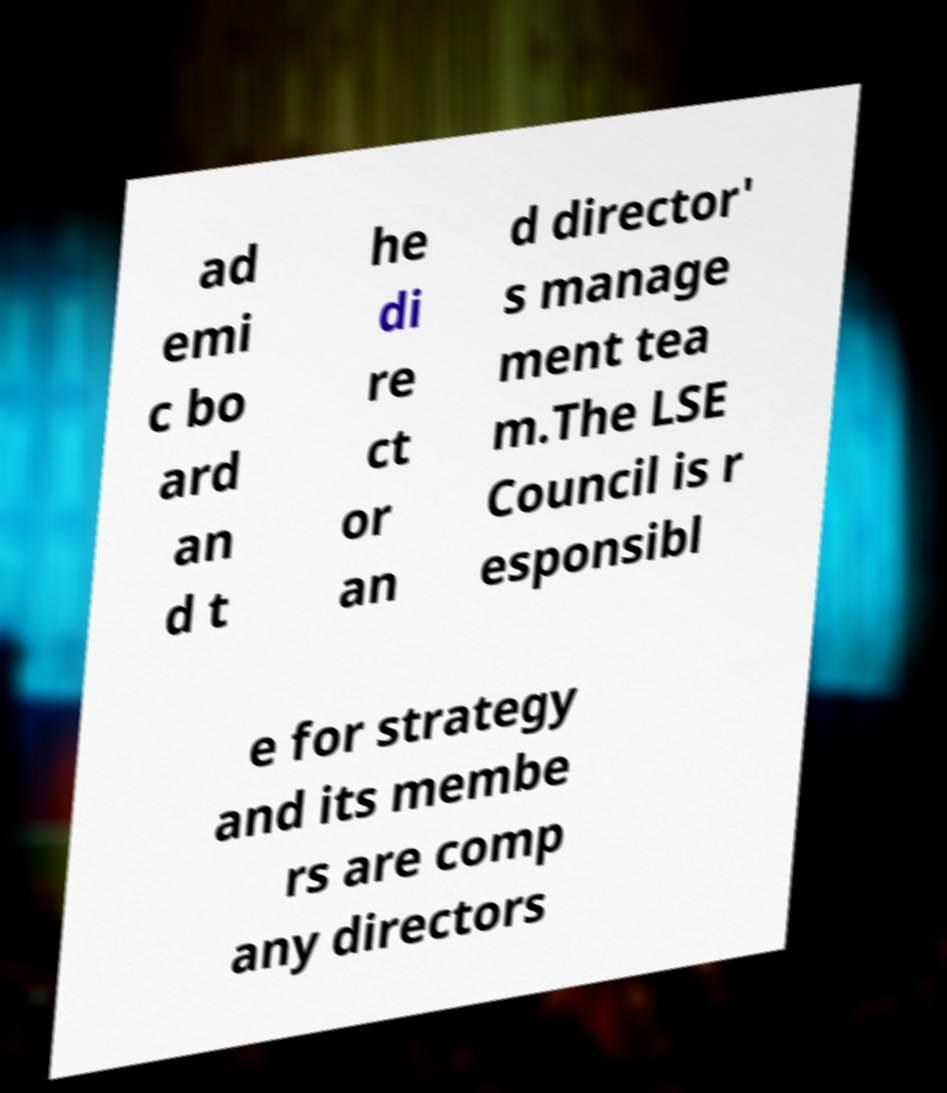Please read and relay the text visible in this image. What does it say? ad emi c bo ard an d t he di re ct or an d director' s manage ment tea m.The LSE Council is r esponsibl e for strategy and its membe rs are comp any directors 